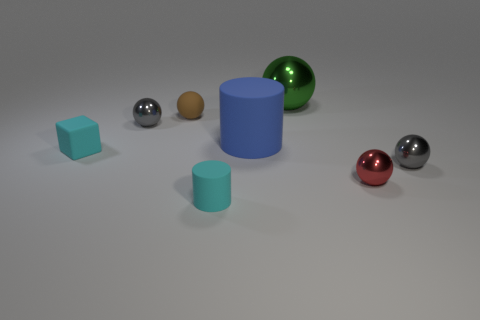Subtract all red spheres. How many spheres are left? 4 Subtract all cyan balls. Subtract all green cubes. How many balls are left? 5 Add 1 big yellow metallic balls. How many objects exist? 9 Subtract all blocks. How many objects are left? 7 Subtract 1 green balls. How many objects are left? 7 Subtract all big green metallic things. Subtract all small spheres. How many objects are left? 3 Add 7 small matte things. How many small matte things are left? 10 Add 7 large green balls. How many large green balls exist? 8 